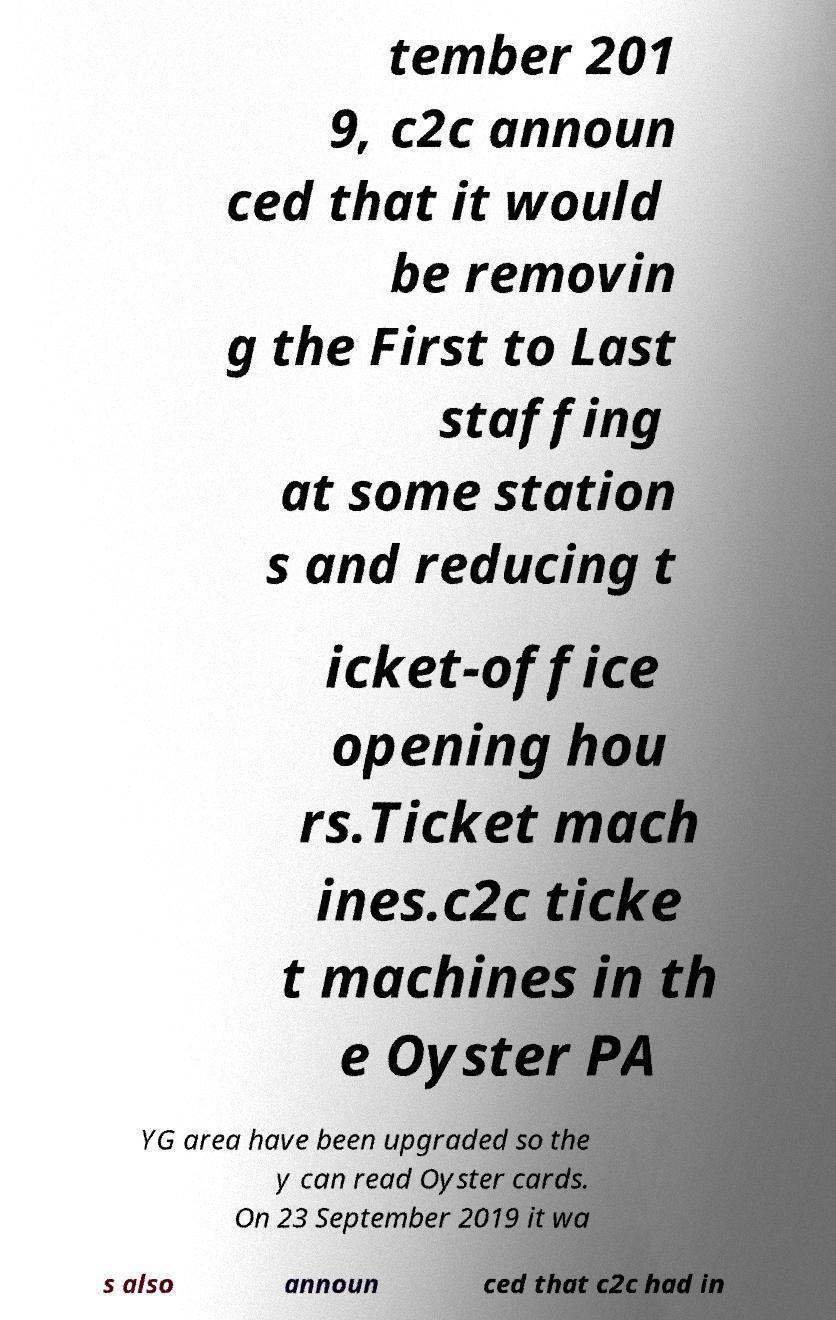There's text embedded in this image that I need extracted. Can you transcribe it verbatim? tember 201 9, c2c announ ced that it would be removin g the First to Last staffing at some station s and reducing t icket-office opening hou rs.Ticket mach ines.c2c ticke t machines in th e Oyster PA YG area have been upgraded so the y can read Oyster cards. On 23 September 2019 it wa s also announ ced that c2c had in 